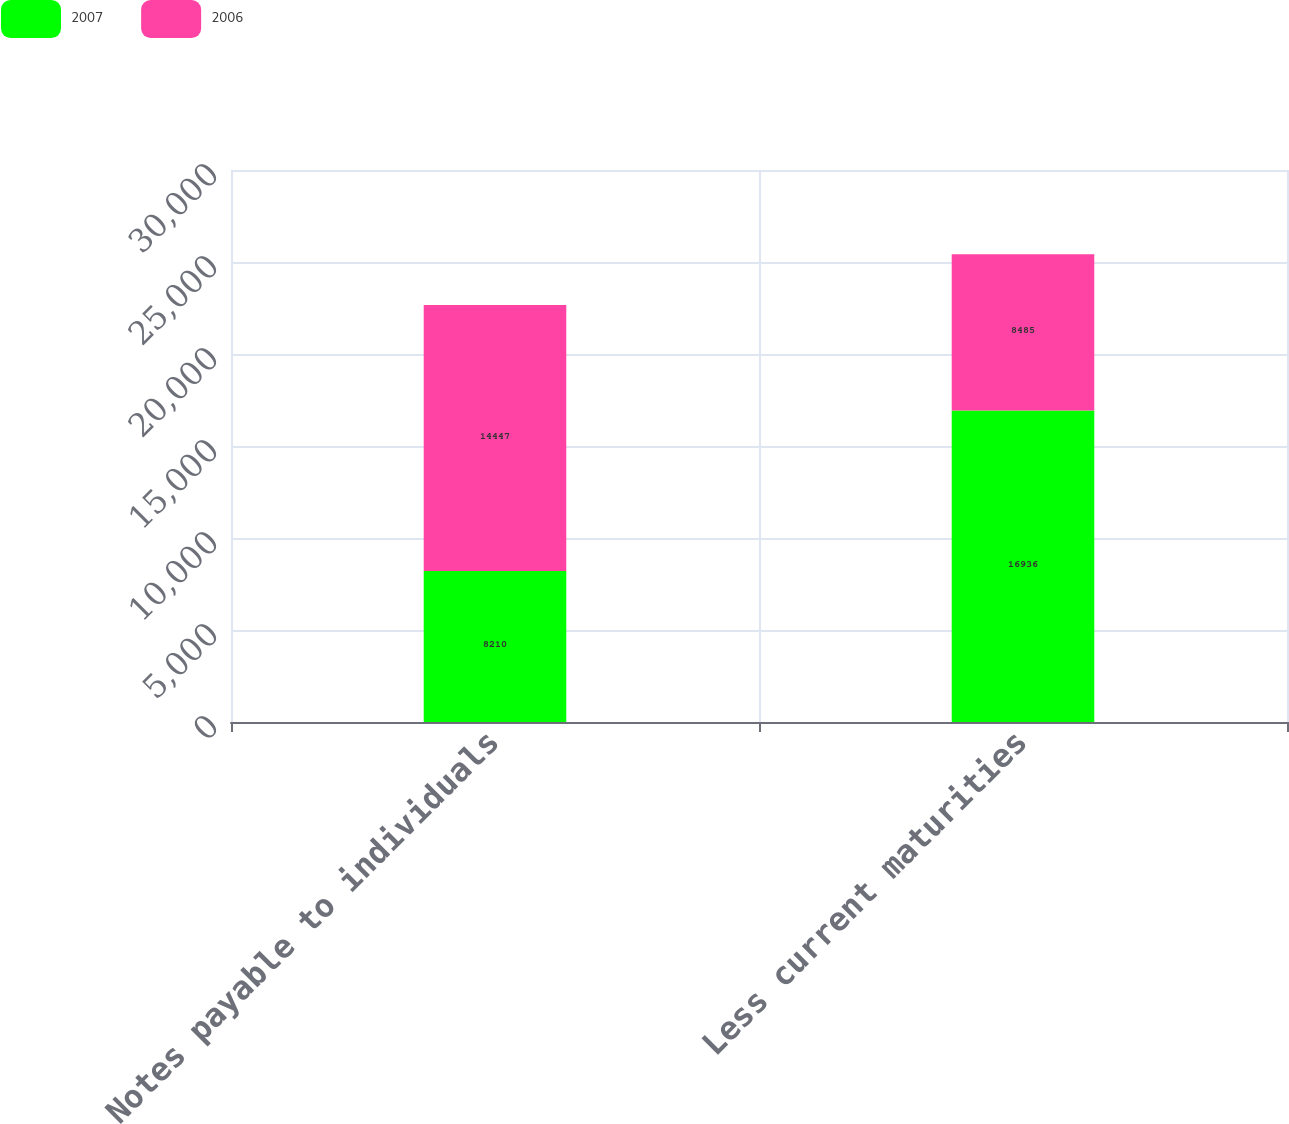Convert chart. <chart><loc_0><loc_0><loc_500><loc_500><stacked_bar_chart><ecel><fcel>Notes payable to individuals<fcel>Less current maturities<nl><fcel>2007<fcel>8210<fcel>16936<nl><fcel>2006<fcel>14447<fcel>8485<nl></chart> 